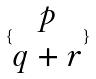Convert formula to latex. <formula><loc_0><loc_0><loc_500><loc_500>\{ \begin{matrix} p \\ q + r \end{matrix} \}</formula> 